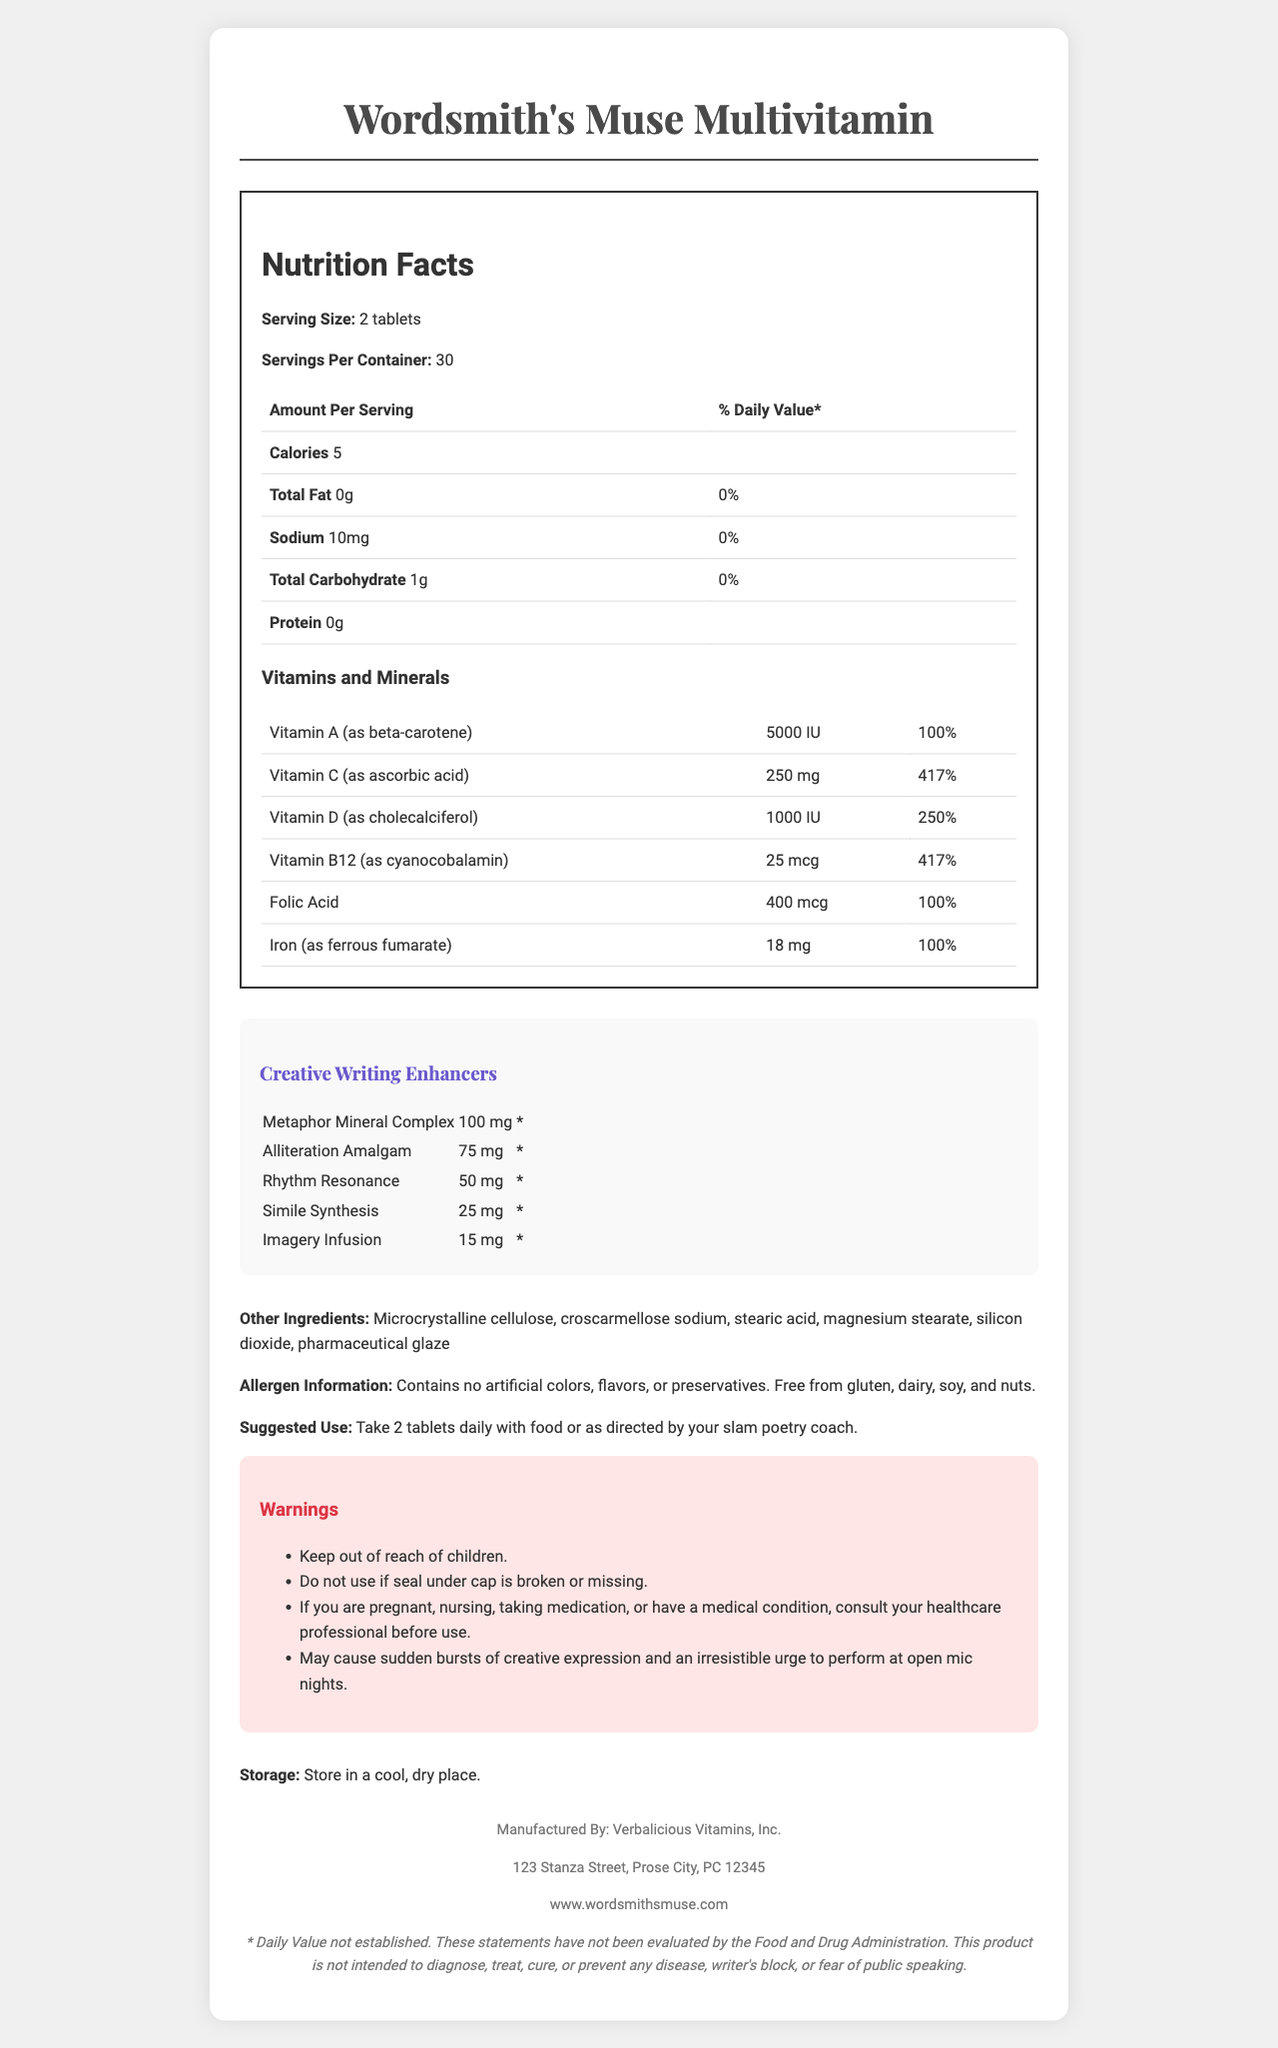what is the serving size? The serving size mentioned in the "Nutrition Facts" section of the document is 2 tablets.
Answer: 2 tablets how many servings are there per container? The document states that there are 30 servings per container.
Answer: 30 how many calories are in each serving? The "Nutrition Facts" section lists 5 calories per serving.
Answer: 5 what percentage of the daily value of Vitamin C does one serving provide? The document shows that one serving provides 250 mg of Vitamin C, which is 417% of the daily value.
Answer: 417% which ingredient is used for the metaphor mineral complex? A. Imagery Infusion B. Alliteration Amalgam C. Metaphor Mineral Complex D. Rhythm Resonance The Creative Writing Enhancers section lists Metaphor Mineral Complex as one of the ingredients.
Answer: C how much sodium is in a serving of this supplement? The "Nutrition Facts" section of the document shows that there are 10 mg of sodium per serving.
Answer: 10 mg is this product free from gluten? The "Allergen Information" section states that the product is free from gluten.
Answer: Yes what is the total carbohydrate content per serving? A. 0g B. 1g C. 5g D. 18mg The "Nutrition Facts" section indicates that the total carbohydrate content per serving is 1g.
Answer: B does the product contain artificial colors, flavors, or preservatives? The "Allergen Information" section mentions that the product contains no artificial colors, flavors, or preservatives.
Answer: No where is the product manufactured? The document states that the product is manufactured by Verbalicious Vitamins, Inc. at 123 Stanza Street, Prose City, PC 12345.
Answer: Verbalicious Vitamins, Inc. what is the suggested use for this multivitamin? The "Suggested Use" section advises to take 2 tablets daily with food or as directed by your slam poetry coach.
Answer: Take 2 tablets daily with food or as directed by your slam poetry coach. what should you do if you are pregnant or nursing before taking this supplement? The "Warnings" section indicates that you should consult your healthcare professional before use if you are pregnant, nursing, taking medication, or have a medical condition.
Answer: Consult your healthcare professional before use. does this product enhance aspects of creative writing? The "Creative Writing Enhancers" section lists multiple ingredients aimed at enhancing aspects of creative writing like Metaphor Mineral Complex and Alliteration Amalgam.
Answer: Yes what is not mentioned in the document about the multivitamin's taste? The document does not provide any information about the taste of the multivitamin.
Answer: Not enough information provide a summary of the document. The document provides a detailed overview of the multivitamin's nutritional content, creative enhancers, and other key product details suitable for a slam poet looking to enhance their creative writing abilities.
Answer: The "Wordsmith's Muse Multivitamin" is a supplement aimed at enhancing creative writing through a blend of vitamins, minerals, and specially formulated enhancers. It features standard nutritional information such as calories, sodium, carbohydrates, and specific vitamins and minerals along with creatively named enhancers. The document also includes details on the serving size, allergen information, suggested use, storage, manufacturer details, and relevant warnings. 